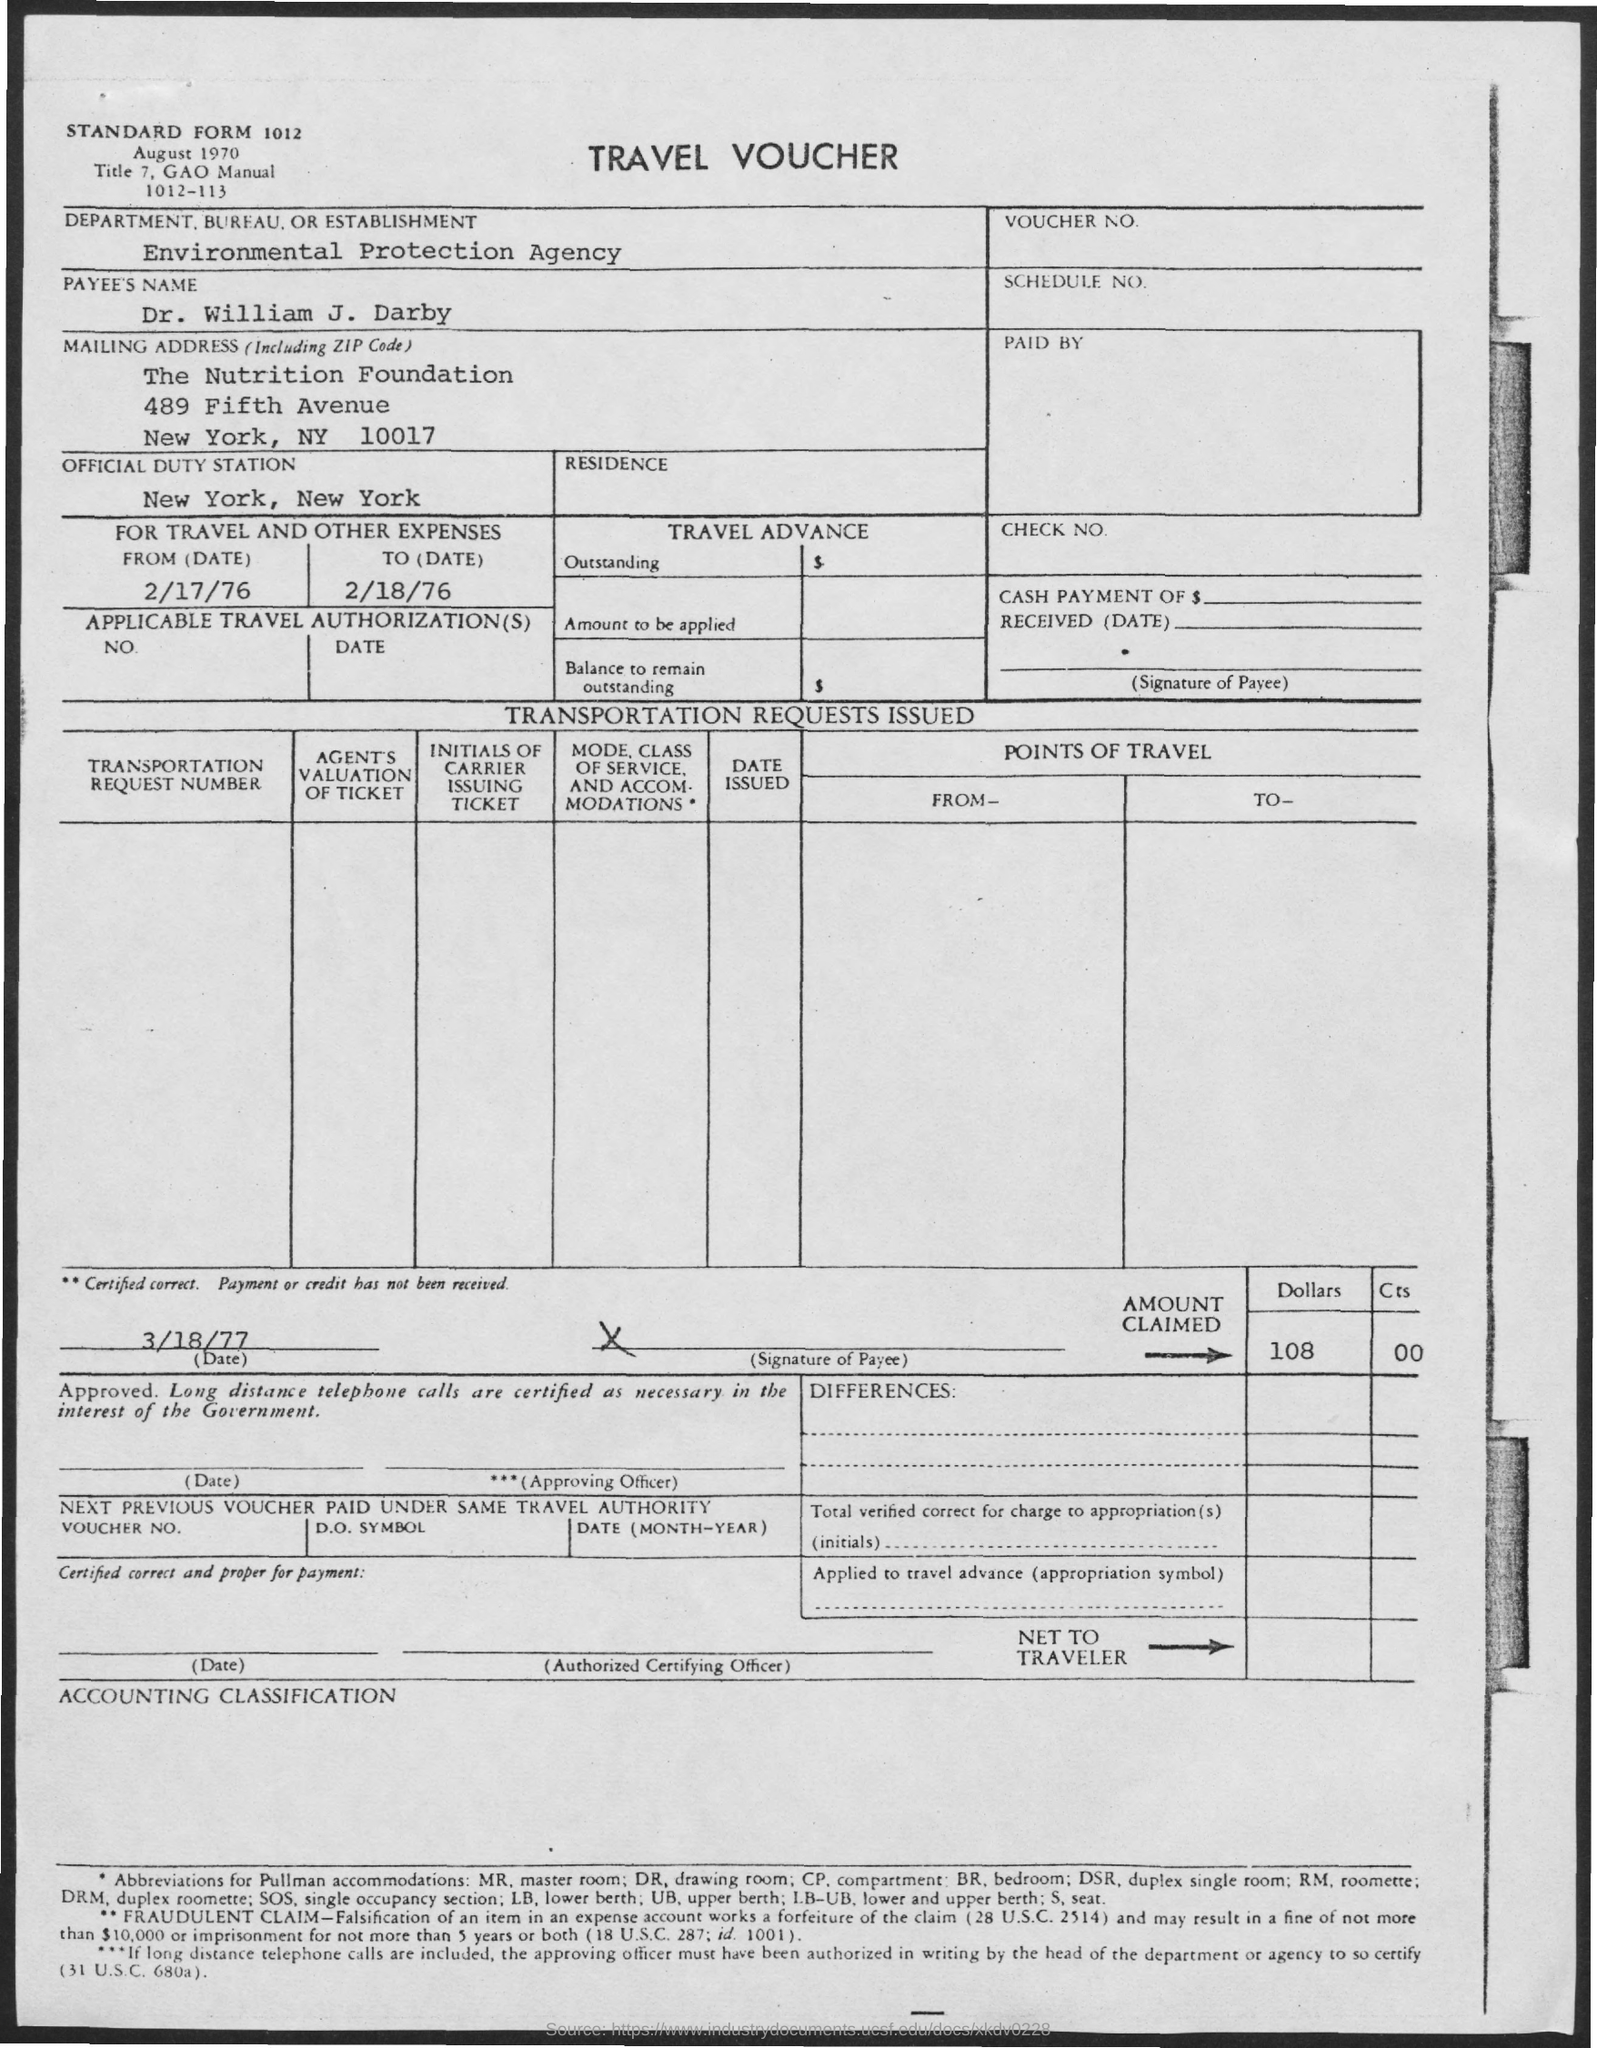What type of document this ?
Offer a terse response. TRAVEL VOUCHER. 